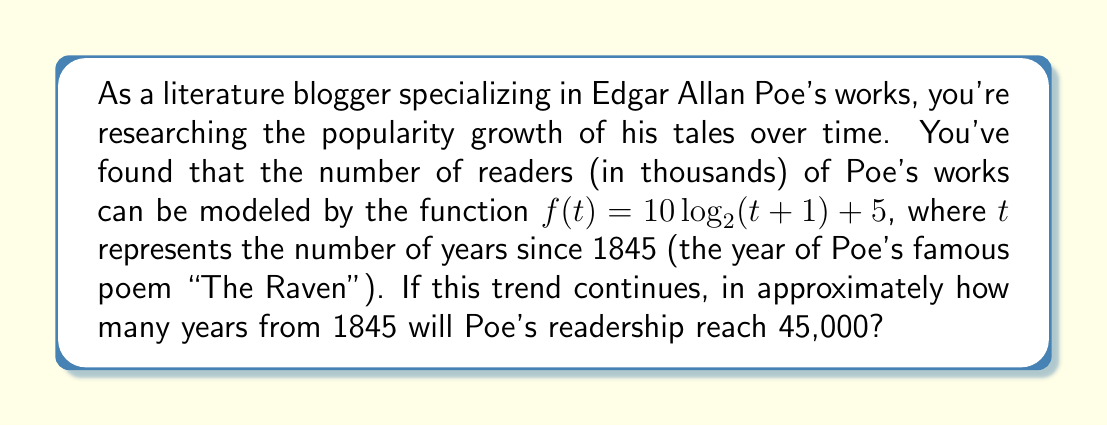Show me your answer to this math problem. Let's approach this step-by-step:

1) We need to solve the equation:
   $f(t) = 45$
   
   This is because 45 in our function represents 45,000 readers.

2) Substituting our function:
   $10 \log_2(t+1) + 5 = 45$

3) Subtract 5 from both sides:
   $10 \log_2(t+1) = 40$

4) Divide both sides by 10:
   $\log_2(t+1) = 4$

5) Now, we need to solve for $t$. We can do this by applying $2^x$ to both sides:
   $2^{\log_2(t+1)} = 2^4$

6) The left side simplifies to just $(t+1)$:
   $t + 1 = 2^4 = 16$

7) Subtract 1 from both sides:
   $t = 15$

Therefore, it will take approximately 15 years from 1845 for Poe's readership to reach 45,000 according to this model.

To verify:
$f(15) = 10 \log_2(15+1) + 5 = 10 \log_2(16) + 5 = 10 * 4 + 5 = 45$
Answer: Approximately 15 years from 1845, or around the year 1860. 